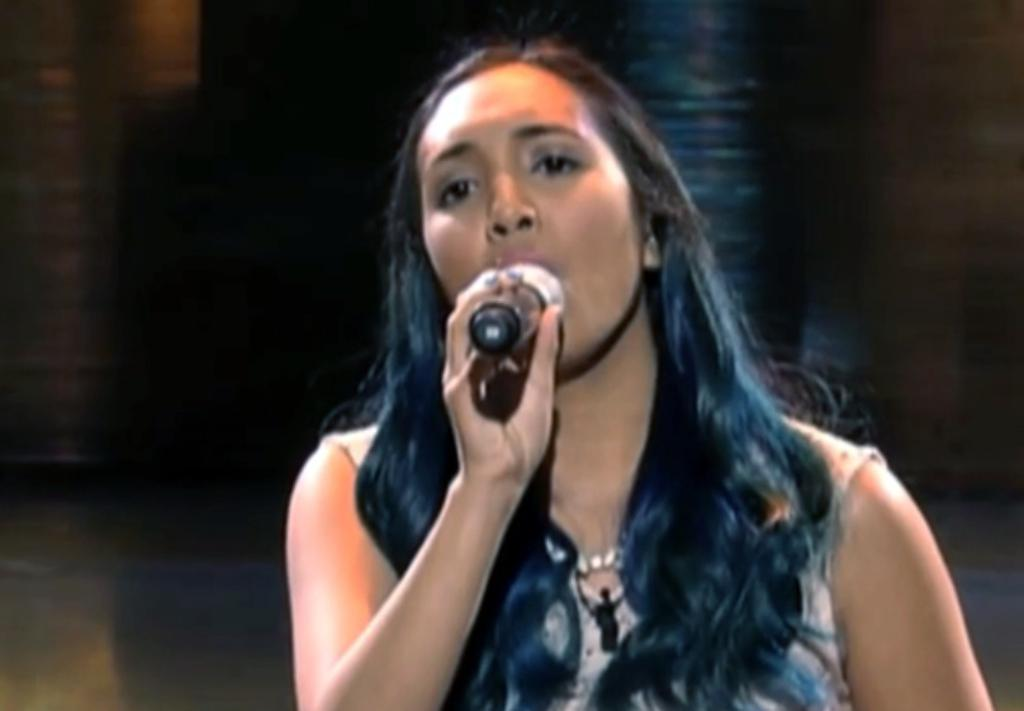Who is the main subject in the image? There is a woman in the image. What is the woman holding in her right hand? The woman is holding a microphone in her right hand. What is the woman doing in the image? The woman is singing. What type of yak can be seen in the background of the image? There is no yak present in the image. How many basketballs are visible in the image? There are no basketballs visible in the image. 